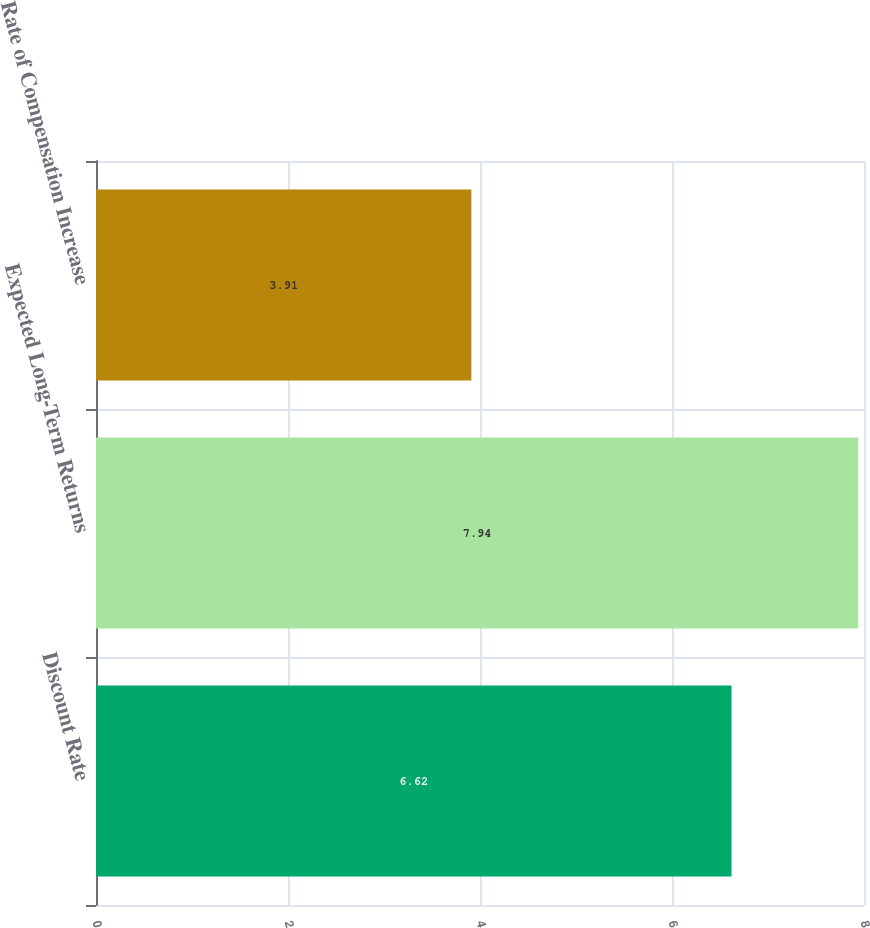<chart> <loc_0><loc_0><loc_500><loc_500><bar_chart><fcel>Discount Rate<fcel>Expected Long-Term Returns<fcel>Rate of Compensation Increase<nl><fcel>6.62<fcel>7.94<fcel>3.91<nl></chart> 